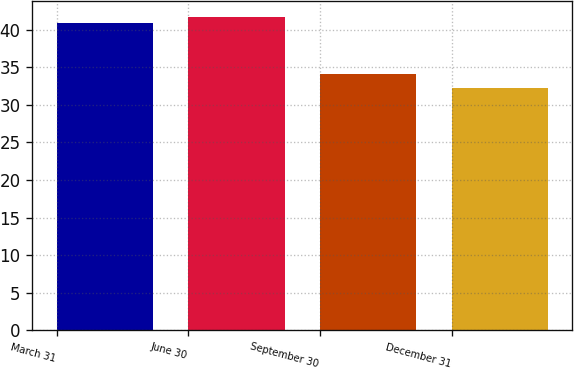<chart> <loc_0><loc_0><loc_500><loc_500><bar_chart><fcel>March 31<fcel>June 30<fcel>September 30<fcel>December 31<nl><fcel>40.9<fcel>41.77<fcel>34.11<fcel>32.3<nl></chart> 